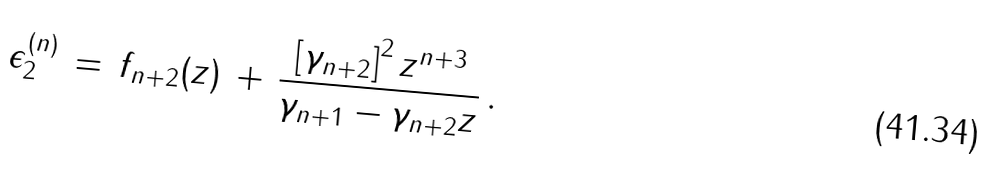<formula> <loc_0><loc_0><loc_500><loc_500>\epsilon _ { 2 } ^ { ( n ) } \, = \, f _ { n + 2 } ( z ) \, + \, \frac { \left [ \gamma _ { n + 2 } \right ] ^ { 2 } z ^ { n + 3 } } { \gamma _ { n + 1 } - \gamma _ { n + 2 } z } \, .</formula> 